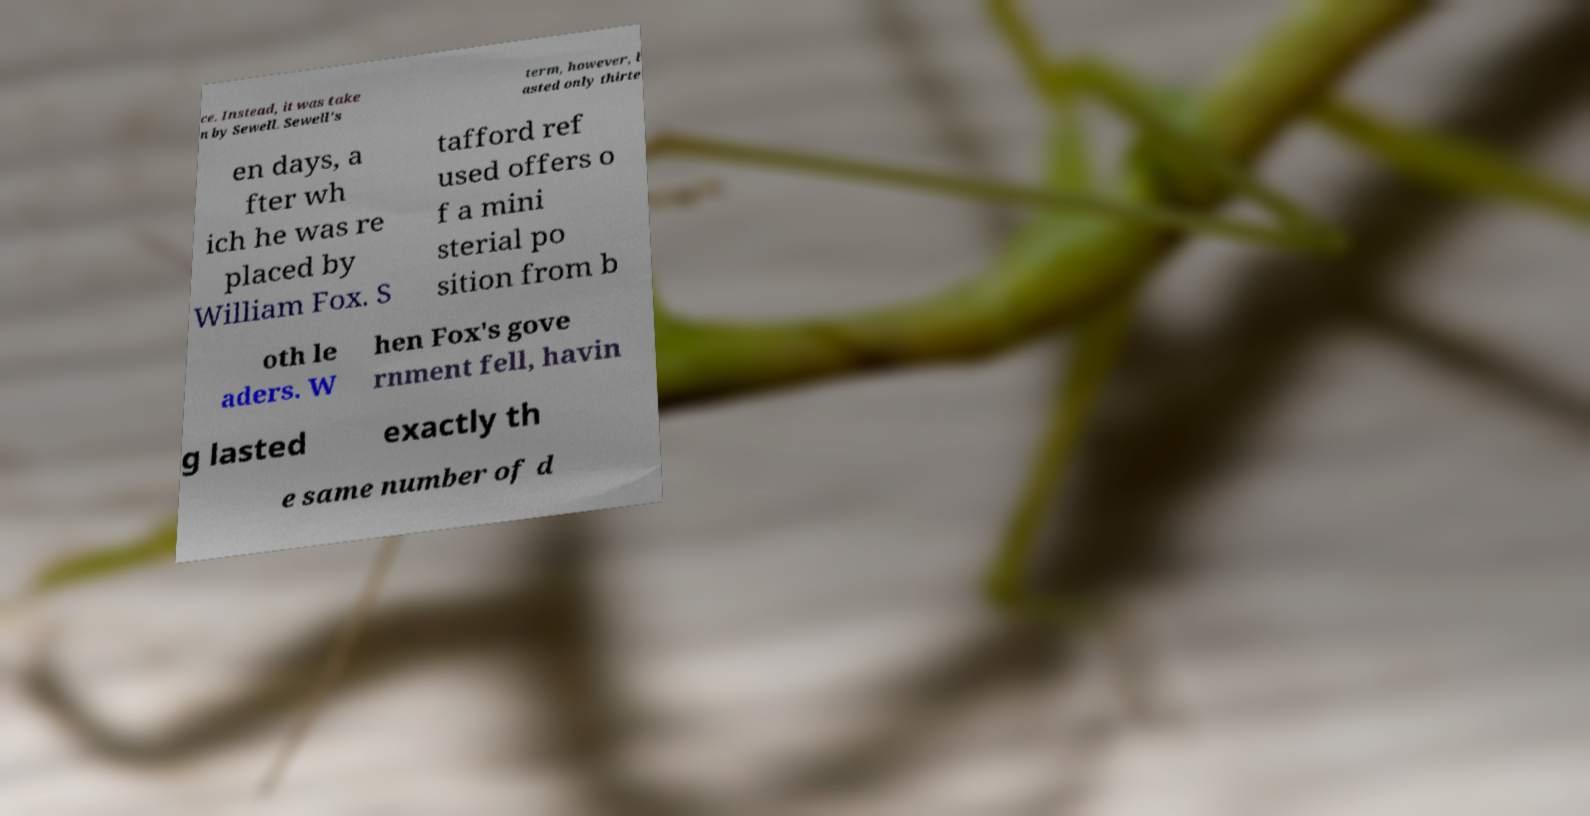For documentation purposes, I need the text within this image transcribed. Could you provide that? ce. Instead, it was take n by Sewell. Sewell's term, however, l asted only thirte en days, a fter wh ich he was re placed by William Fox. S tafford ref used offers o f a mini sterial po sition from b oth le aders. W hen Fox's gove rnment fell, havin g lasted exactly th e same number of d 